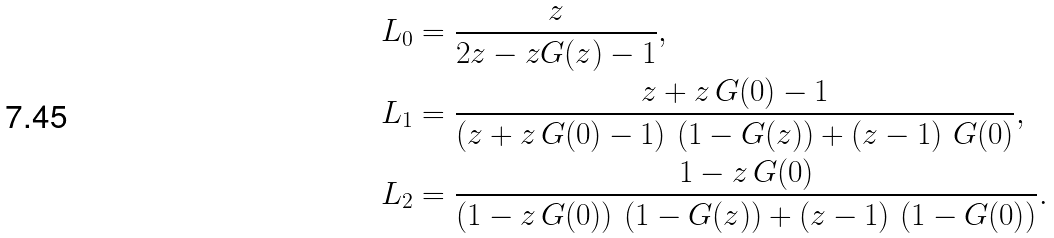Convert formula to latex. <formula><loc_0><loc_0><loc_500><loc_500>L _ { 0 } & = \frac { z } { 2 z - z G ( z ) - 1 } , \\ L _ { 1 } & = \frac { z + z \, G ( 0 ) - 1 } { \left ( z + z \, G ( 0 ) - 1 \right ) \, \left ( 1 - G ( z ) \right ) + \left ( z - 1 \right ) \, G ( 0 ) } , \\ L _ { 2 } & = \frac { 1 - z \, G ( 0 ) } { \left ( 1 - z \, G ( 0 ) \right ) \, \left ( 1 - G ( z ) \right ) + \left ( z - 1 \right ) \, \left ( 1 - G ( 0 ) \right ) } .</formula> 